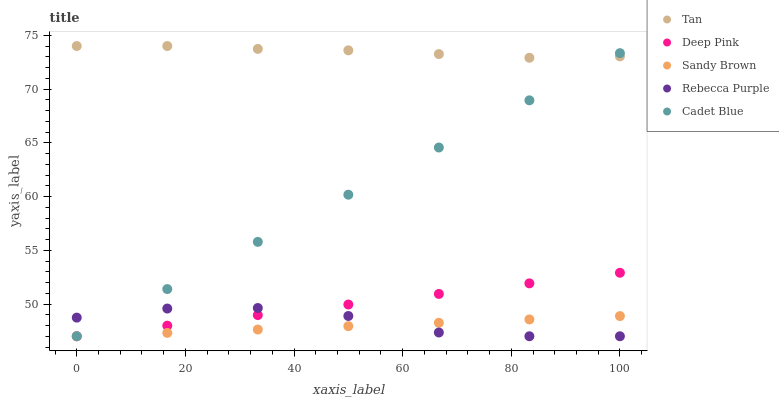Does Sandy Brown have the minimum area under the curve?
Answer yes or no. Yes. Does Tan have the maximum area under the curve?
Answer yes or no. Yes. Does Deep Pink have the minimum area under the curve?
Answer yes or no. No. Does Deep Pink have the maximum area under the curve?
Answer yes or no. No. Is Cadet Blue the smoothest?
Answer yes or no. Yes. Is Rebecca Purple the roughest?
Answer yes or no. Yes. Is Tan the smoothest?
Answer yes or no. No. Is Tan the roughest?
Answer yes or no. No. Does Cadet Blue have the lowest value?
Answer yes or no. Yes. Does Tan have the lowest value?
Answer yes or no. No. Does Tan have the highest value?
Answer yes or no. Yes. Does Deep Pink have the highest value?
Answer yes or no. No. Is Sandy Brown less than Tan?
Answer yes or no. Yes. Is Tan greater than Deep Pink?
Answer yes or no. Yes. Does Sandy Brown intersect Cadet Blue?
Answer yes or no. Yes. Is Sandy Brown less than Cadet Blue?
Answer yes or no. No. Is Sandy Brown greater than Cadet Blue?
Answer yes or no. No. Does Sandy Brown intersect Tan?
Answer yes or no. No. 